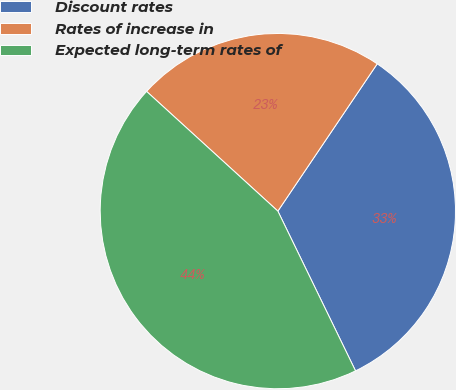Convert chart. <chart><loc_0><loc_0><loc_500><loc_500><pie_chart><fcel>Discount rates<fcel>Rates of increase in<fcel>Expected long-term rates of<nl><fcel>33.35%<fcel>22.68%<fcel>43.97%<nl></chart> 